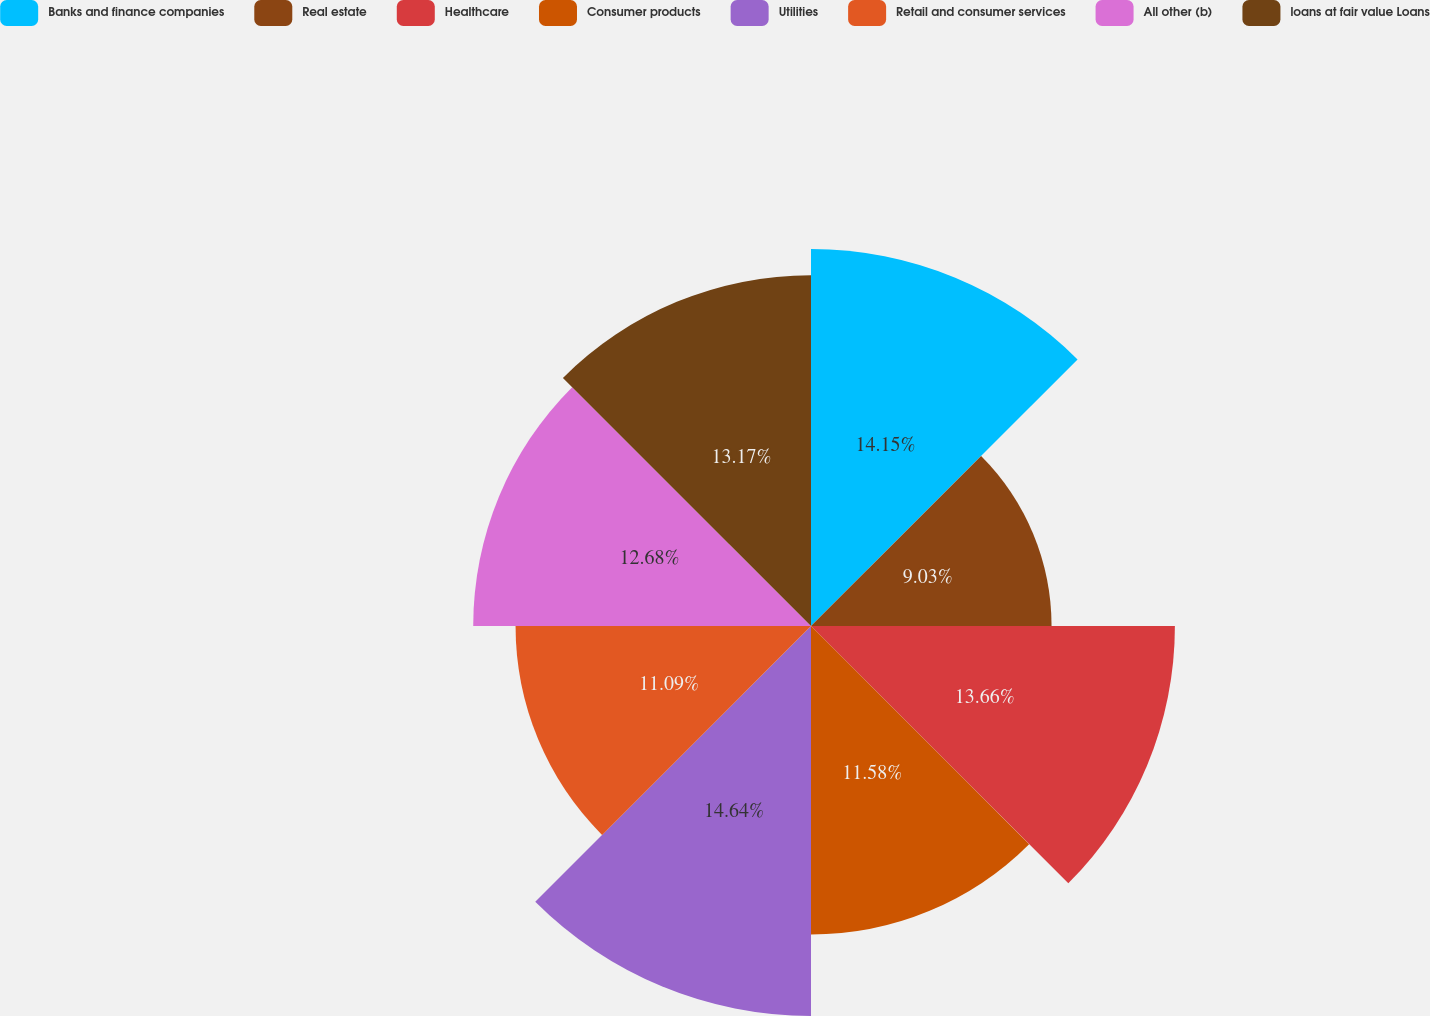Convert chart. <chart><loc_0><loc_0><loc_500><loc_500><pie_chart><fcel>Banks and finance companies<fcel>Real estate<fcel>Healthcare<fcel>Consumer products<fcel>Utilities<fcel>Retail and consumer services<fcel>All other (b)<fcel>loans at fair value Loans<nl><fcel>14.15%<fcel>9.03%<fcel>13.66%<fcel>11.58%<fcel>14.64%<fcel>11.09%<fcel>12.68%<fcel>13.17%<nl></chart> 